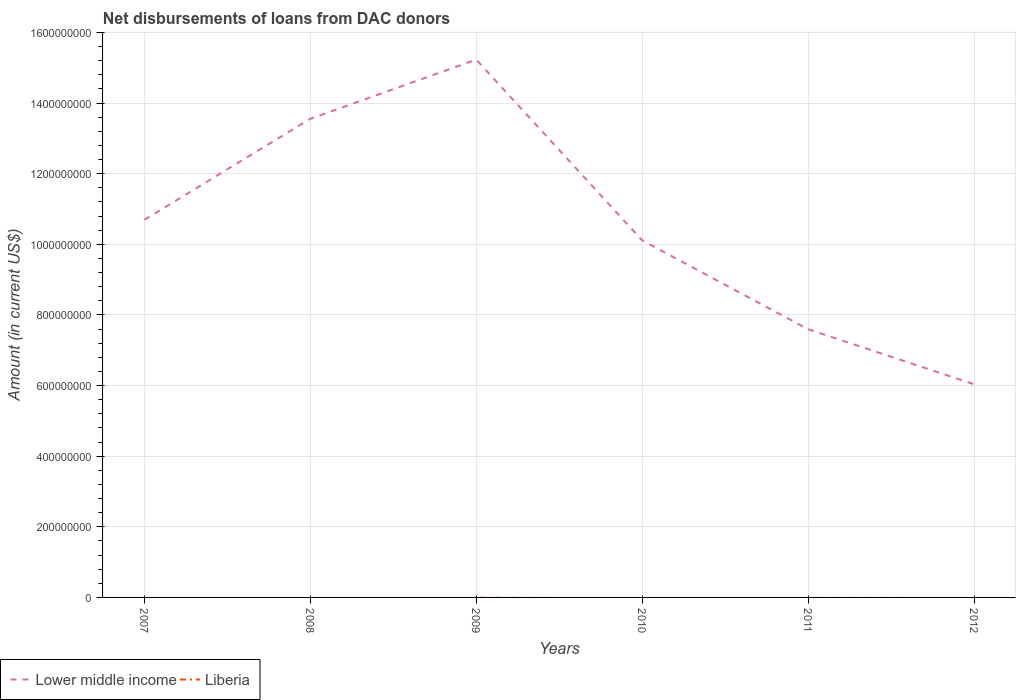Across all years, what is the maximum amount of loans disbursed in Lower middle income?
Offer a very short reply. 6.04e+08. What is the total amount of loans disbursed in Lower middle income in the graph?
Your response must be concise. 7.52e+08. What is the difference between the highest and the second highest amount of loans disbursed in Lower middle income?
Your answer should be compact. 9.19e+08. What is the difference between the highest and the lowest amount of loans disbursed in Lower middle income?
Give a very brief answer. 3. Is the amount of loans disbursed in Liberia strictly greater than the amount of loans disbursed in Lower middle income over the years?
Offer a terse response. Yes. How many lines are there?
Give a very brief answer. 1. How many years are there in the graph?
Provide a succinct answer. 6. Are the values on the major ticks of Y-axis written in scientific E-notation?
Give a very brief answer. No. Does the graph contain any zero values?
Provide a succinct answer. Yes. Where does the legend appear in the graph?
Your answer should be very brief. Bottom left. How many legend labels are there?
Ensure brevity in your answer.  2. How are the legend labels stacked?
Keep it short and to the point. Horizontal. What is the title of the graph?
Your answer should be very brief. Net disbursements of loans from DAC donors. What is the label or title of the X-axis?
Provide a short and direct response. Years. What is the label or title of the Y-axis?
Your answer should be compact. Amount (in current US$). What is the Amount (in current US$) in Lower middle income in 2007?
Your response must be concise. 1.07e+09. What is the Amount (in current US$) of Lower middle income in 2008?
Keep it short and to the point. 1.36e+09. What is the Amount (in current US$) of Lower middle income in 2009?
Give a very brief answer. 1.52e+09. What is the Amount (in current US$) in Lower middle income in 2010?
Provide a succinct answer. 1.01e+09. What is the Amount (in current US$) in Liberia in 2010?
Your response must be concise. 0. What is the Amount (in current US$) of Lower middle income in 2011?
Give a very brief answer. 7.59e+08. What is the Amount (in current US$) of Lower middle income in 2012?
Your response must be concise. 6.04e+08. What is the Amount (in current US$) of Liberia in 2012?
Make the answer very short. 0. Across all years, what is the maximum Amount (in current US$) in Lower middle income?
Your answer should be very brief. 1.52e+09. Across all years, what is the minimum Amount (in current US$) in Lower middle income?
Keep it short and to the point. 6.04e+08. What is the total Amount (in current US$) of Lower middle income in the graph?
Offer a very short reply. 6.32e+09. What is the total Amount (in current US$) of Liberia in the graph?
Make the answer very short. 0. What is the difference between the Amount (in current US$) in Lower middle income in 2007 and that in 2008?
Offer a very short reply. -2.86e+08. What is the difference between the Amount (in current US$) of Lower middle income in 2007 and that in 2009?
Provide a short and direct response. -4.54e+08. What is the difference between the Amount (in current US$) in Lower middle income in 2007 and that in 2010?
Your answer should be very brief. 5.83e+07. What is the difference between the Amount (in current US$) in Lower middle income in 2007 and that in 2011?
Make the answer very short. 3.10e+08. What is the difference between the Amount (in current US$) of Lower middle income in 2007 and that in 2012?
Your response must be concise. 4.66e+08. What is the difference between the Amount (in current US$) in Lower middle income in 2008 and that in 2009?
Ensure brevity in your answer.  -1.68e+08. What is the difference between the Amount (in current US$) in Lower middle income in 2008 and that in 2010?
Make the answer very short. 3.44e+08. What is the difference between the Amount (in current US$) of Lower middle income in 2008 and that in 2011?
Keep it short and to the point. 5.96e+08. What is the difference between the Amount (in current US$) in Lower middle income in 2008 and that in 2012?
Your response must be concise. 7.52e+08. What is the difference between the Amount (in current US$) in Lower middle income in 2009 and that in 2010?
Your answer should be compact. 5.12e+08. What is the difference between the Amount (in current US$) of Lower middle income in 2009 and that in 2011?
Give a very brief answer. 7.64e+08. What is the difference between the Amount (in current US$) of Lower middle income in 2009 and that in 2012?
Ensure brevity in your answer.  9.19e+08. What is the difference between the Amount (in current US$) in Lower middle income in 2010 and that in 2011?
Make the answer very short. 2.52e+08. What is the difference between the Amount (in current US$) of Lower middle income in 2010 and that in 2012?
Your answer should be compact. 4.07e+08. What is the difference between the Amount (in current US$) in Lower middle income in 2011 and that in 2012?
Your answer should be compact. 1.56e+08. What is the average Amount (in current US$) in Lower middle income per year?
Give a very brief answer. 1.05e+09. What is the ratio of the Amount (in current US$) of Lower middle income in 2007 to that in 2008?
Your response must be concise. 0.79. What is the ratio of the Amount (in current US$) of Lower middle income in 2007 to that in 2009?
Make the answer very short. 0.7. What is the ratio of the Amount (in current US$) of Lower middle income in 2007 to that in 2010?
Ensure brevity in your answer.  1.06. What is the ratio of the Amount (in current US$) of Lower middle income in 2007 to that in 2011?
Provide a succinct answer. 1.41. What is the ratio of the Amount (in current US$) of Lower middle income in 2007 to that in 2012?
Keep it short and to the point. 1.77. What is the ratio of the Amount (in current US$) in Lower middle income in 2008 to that in 2009?
Ensure brevity in your answer.  0.89. What is the ratio of the Amount (in current US$) in Lower middle income in 2008 to that in 2010?
Your answer should be very brief. 1.34. What is the ratio of the Amount (in current US$) in Lower middle income in 2008 to that in 2011?
Offer a terse response. 1.78. What is the ratio of the Amount (in current US$) in Lower middle income in 2008 to that in 2012?
Your answer should be very brief. 2.25. What is the ratio of the Amount (in current US$) of Lower middle income in 2009 to that in 2010?
Your answer should be very brief. 1.51. What is the ratio of the Amount (in current US$) in Lower middle income in 2009 to that in 2011?
Offer a terse response. 2.01. What is the ratio of the Amount (in current US$) of Lower middle income in 2009 to that in 2012?
Make the answer very short. 2.52. What is the ratio of the Amount (in current US$) of Lower middle income in 2010 to that in 2011?
Give a very brief answer. 1.33. What is the ratio of the Amount (in current US$) in Lower middle income in 2010 to that in 2012?
Provide a succinct answer. 1.67. What is the ratio of the Amount (in current US$) of Lower middle income in 2011 to that in 2012?
Provide a short and direct response. 1.26. What is the difference between the highest and the second highest Amount (in current US$) of Lower middle income?
Offer a terse response. 1.68e+08. What is the difference between the highest and the lowest Amount (in current US$) of Lower middle income?
Your response must be concise. 9.19e+08. 